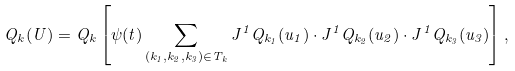Convert formula to latex. <formula><loc_0><loc_0><loc_500><loc_500>Q _ { k } ( U ) = Q _ { k } \left [ \psi ( t ) \sum _ { ( k _ { 1 } , k _ { 2 } , k _ { 3 } ) \in T _ { k } } J ^ { 1 } Q _ { k _ { 1 } } ( u _ { 1 } ) \cdot J ^ { 1 } Q _ { k _ { 2 } } ( u _ { 2 } ) \cdot J ^ { 1 } Q _ { k _ { 3 } } ( u _ { 3 } ) \right ] ,</formula> 